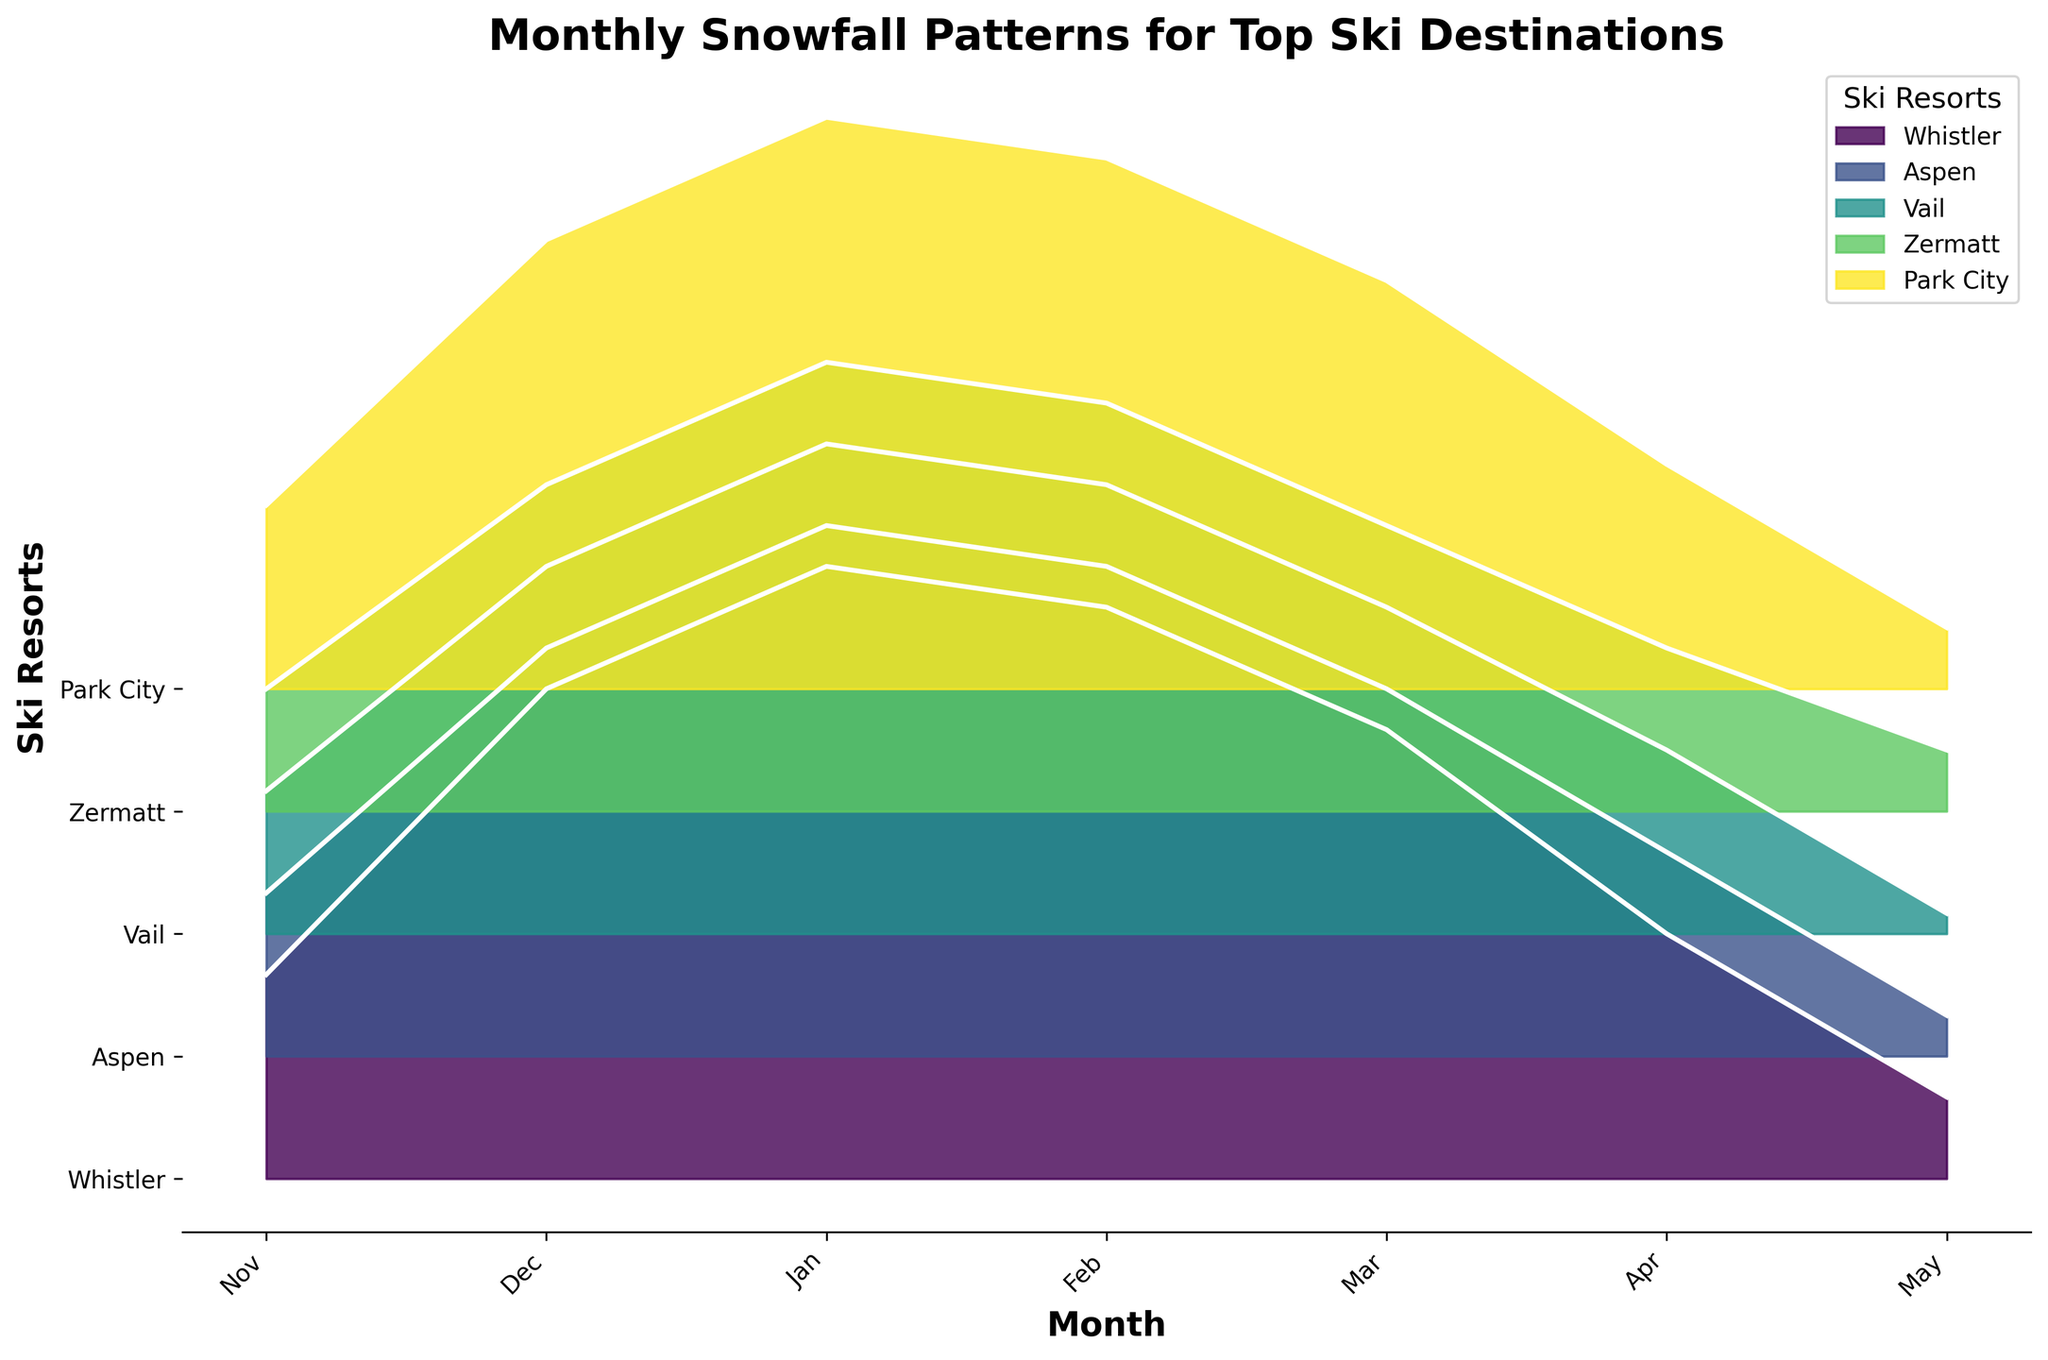Which ski resort has the highest snowfall in January? Look for the peak of each ridgeline in January. Whistler has the highest peak in January.
Answer: Whistler What is the average snowfall for Vail in the months of December and January? Find the snowfall for Vail in December (90) and January (120) and calculate the average: (90 + 120) / 2.
Answer: 105 Which ski resort experiences a decline in snowfall from January to February? Compare the height of the ridgeline peaks between January and February for each resort. Both Whistler and Aspen see a drop in snowfall from January to February.
Answer: Whistler, Aspen During which month does Park City have the minimum snowfall? Observe the ridgeline for Park City and identify the month where its peak is the lowest. May has the smallest peak.
Answer: May Which month has the second-highest average snowfall across all ski resorts? Calculate the average snowfall for each month. The highest average corresponds to January, and the second-highest average corresponds to February.
Answer: February Which ski resorts have more snowfall in November than in May? Compare the height of the ridgeline peaks for each resort between November and May. Whistler, Aspen, Vail, and Park City have more snowfall in November than in May.
Answer: Whistler, Aspen, Vail, Park City How does the snowfall in Zermatt change from March to April? Examine the ridgeline for Zermatt, noting the height difference between March (70) and April (40). Snowfall decreases in Zermatt from March to April.
Answer: Decreases What is the total snowfall in December for Whistler, Aspen, and Vail combined? Add the snowfall values for December from Whistler (120), Aspen (100), and Vail (90): 120 + 100 + 90.
Answer: 310 How does the snowfall pattern in Whistler compare to that in Vail over the months? Analyze the peaks in Whistler versus Vail across each month. Whistler consistently has higher snowfall peaks than Vail.
Answer: Whistler has more snowfall In which month does Aspen have its highest snowfall? Identify the month where Aspen's ridgeline peak is the highest. January shows the highest peak for Aspen.
Answer: January 